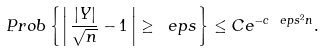<formula> <loc_0><loc_0><loc_500><loc_500>P r o b \left \{ \left | \, \frac { | Y | } { \sqrt { n } } - 1 \, \right | \geq \ e p s \right \} \leq C e ^ { - c \ e p s ^ { 2 } n } .</formula> 